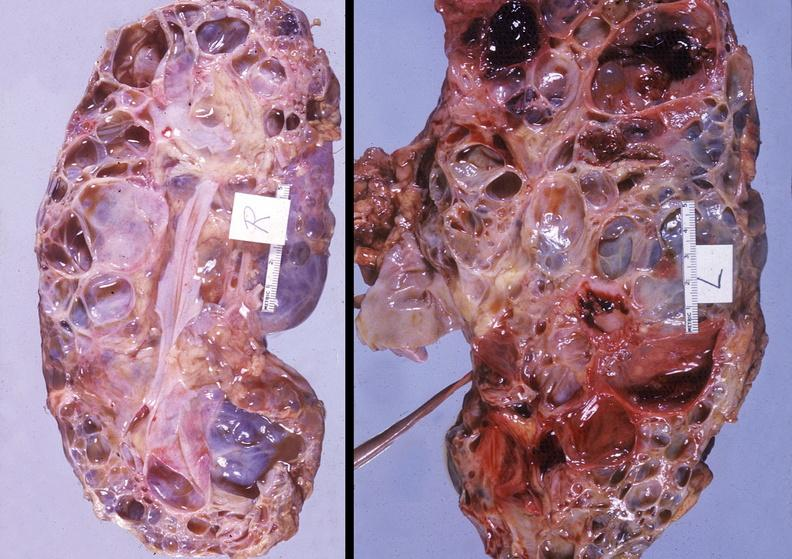does stomach show kidney, polycystic disease?
Answer the question using a single word or phrase. No 